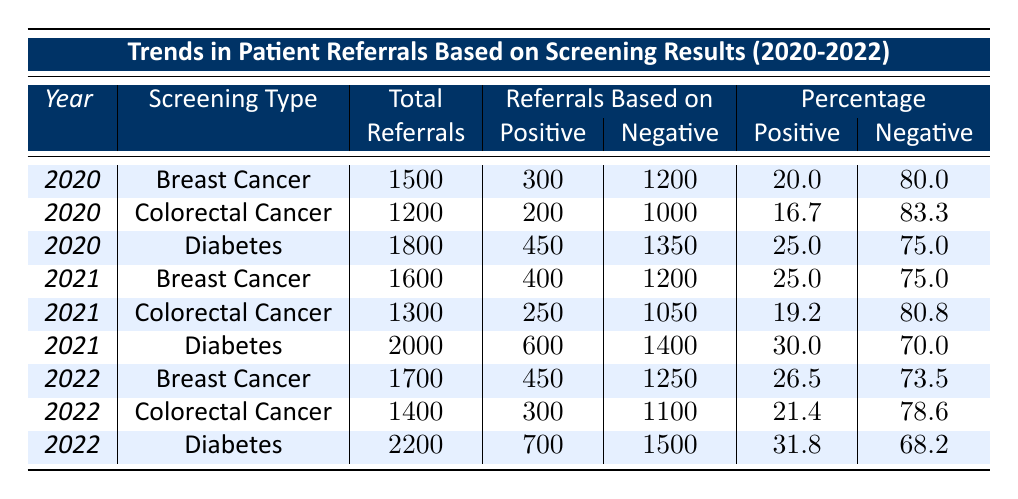What was the total number of referrals for Diabetes in 2021? In the table, for 2021 under Diabetes, the total number of referrals is listed as 2000.
Answer: 2000 What percentage of referrals for Breast Cancer were based on positive results in 2020? Referring to the table for 2020, the percentage of positive referrals for Breast Cancer is 20.0%.
Answer: 20.0% How many referrals were based on negative results for Colorectal Cancer in 2022? The table shows that for Colorectal Cancer in 2022, the referrals based on negative results is 1100.
Answer: 1100 Which screening type had the highest total referrals in 2022? By looking at the total referrals for each screening type in 2022, Diabetes has the highest at 2200.
Answer: Diabetes What is the total number of referrals for all screening types combined in 2020? Adding the total referrals from 2020 for all screening types: 1500 (Breast Cancer) + 1200 (Colorectal Cancer) + 1800 (Diabetes) = 4500.
Answer: 4500 Did the percentage of positive referrals for Diabetes increase from 2020 to 2021? The percentage of positive referrals for Diabetes in 2020 was 25.0%, and in 2021 it increased to 30.0%, indicating an increase.
Answer: Yes What is the average percentage of positive referrals across all screening types in 2022? To find the average percentage for 2022: (26.5 + 21.4 + 31.8) / 3 = 26.3.
Answer: 26.3 Which year saw the highest increase in referrals for Breast Cancer? Comparing the total referrals for Breast Cancer across the years: 2020 had 1500, 2021 had 1600 (+100), and 2022 had 1700 (+100). The highest increase is not maximized in any single year; both show the same rise of 100. Therefore, it remained consistent.
Answer: Both years How many total referrals were based on positive results for Diabetes from 2020 to 2022? Adding the positive referrals for Diabetes across all three years: 450 (2020) + 600 (2021) + 700 (2022) = 1750.
Answer: 1750 Which screening type had the lowest percentage of positive referrals in 2021? Looking at the percentages for 2021: Breast Cancer (25.0%), Colorectal Cancer (19.2%), and Diabetes (30.0%), the lowest is Colorectal Cancer at 19.2%.
Answer: Colorectal Cancer 